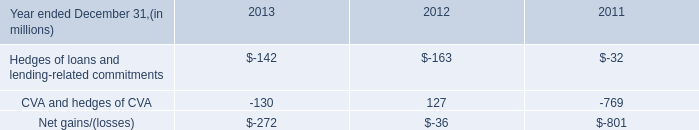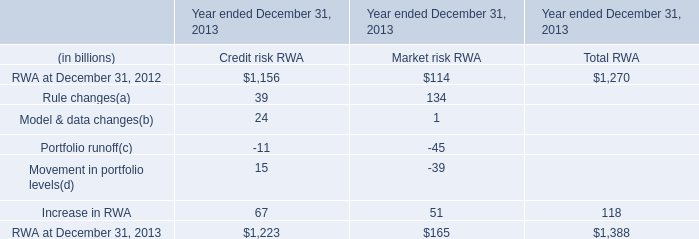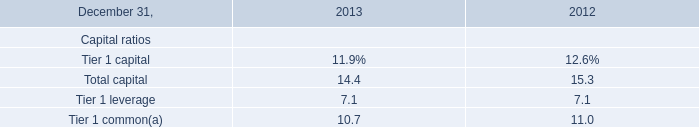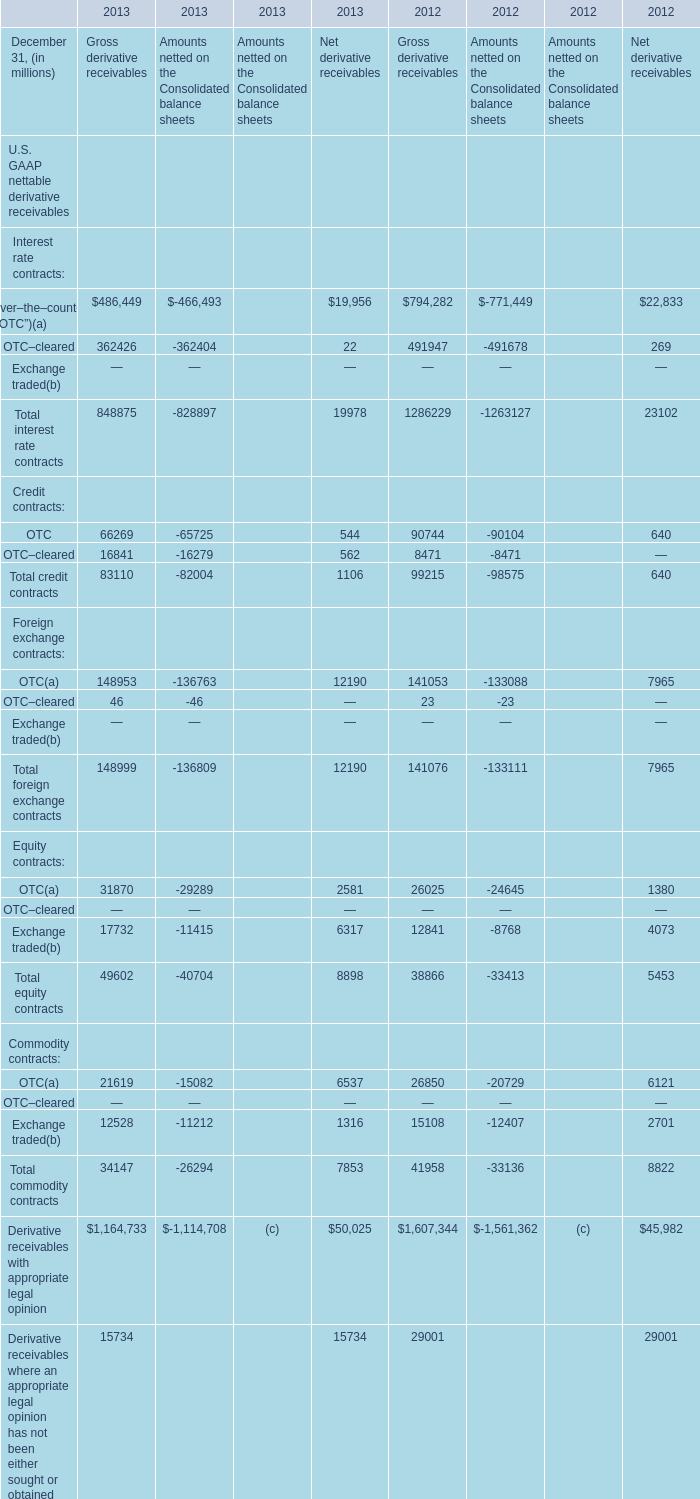at december 31 , 2013 what is the dollar amount of the cra loan portfolio that was not performing and charged off , in billions? 
Computations: (18 * 3%)
Answer: 0.54. 